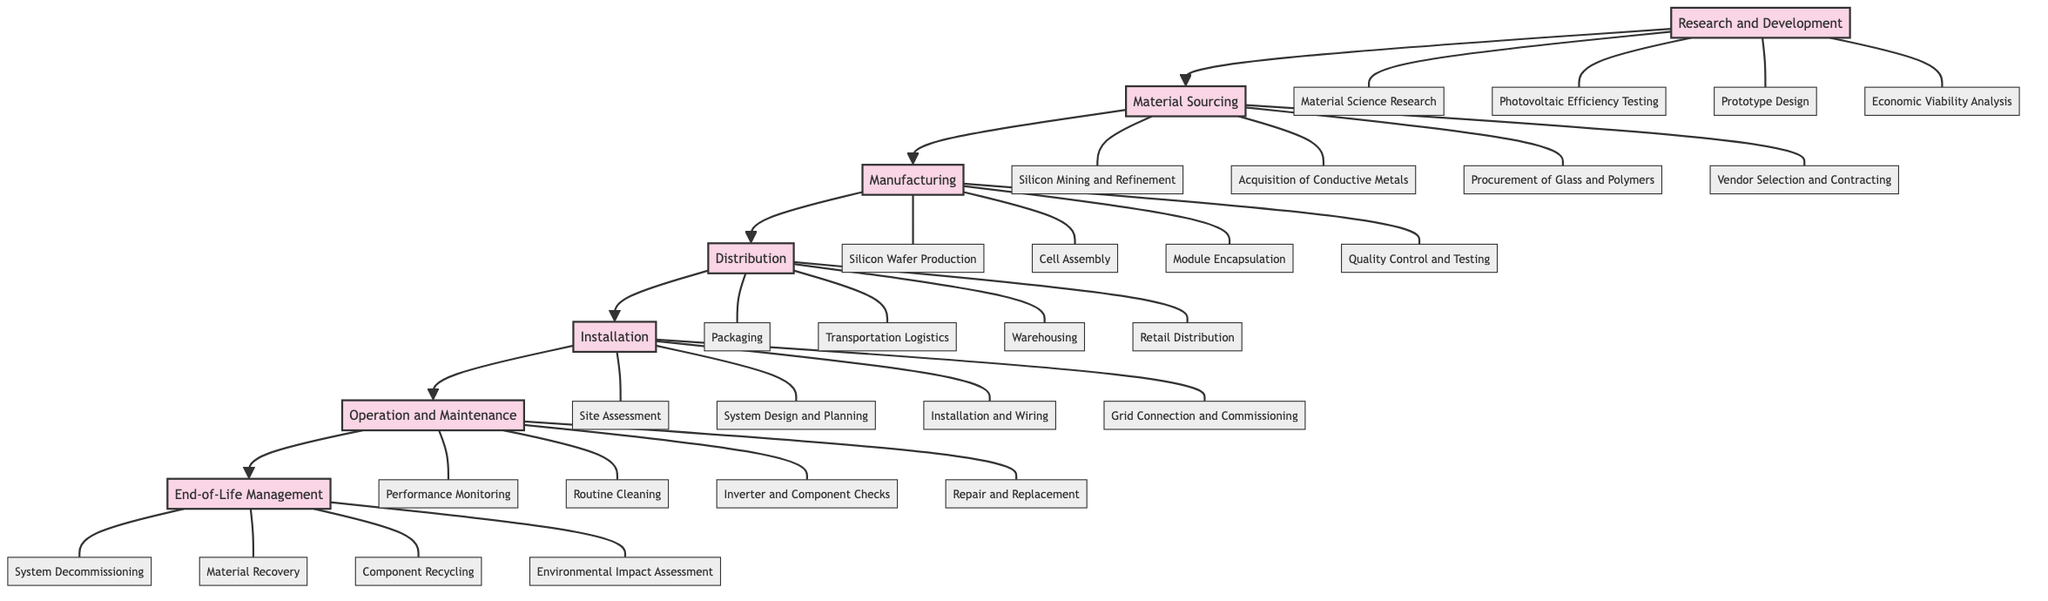What is the first phase in the lifecycle of a solar panel? The diagram indicates that the lifecycle begins with the phase "Research and Development," which is the first node in the sequence.
Answer: Research and Development How many activities are listed under the "Manufacturing" phase? The "Manufacturing" phase contains four activities: "Silicon Wafer Production," "Cell Assembly," "Module Encapsulation," and "Quality Control and Testing." Counting these gives a total of four activities.
Answer: 4 What is the last phase before "End-of-Life Management"? The diagram shows that "Operation and Maintenance" comes directly before "End-of-Life Management" in the flow, which indicates that it is the preceding phase.
Answer: Operation and Maintenance Which activity is the second in the "Distribution" phase? The activities under the "Distribution" phase are listed in order. The second activity listed is "Transportation Logistics."
Answer: Transportation Logistics What are the two main activities in the "Installation" phase? The diagram provides four activities under the "Installation" phase, but the two main activities would refer to the first two listed: "Site Assessment" and "System Design and Planning."
Answer: Site Assessment, System Design and Planning If a solar panel is decommissioned, which phase does it enter next? According to the flow in the diagram, once a solar panel is decommissioned in the "End-of-Life Management" phase, there are no subsequent phases, indicating it is the final step in the lifecycle.
Answer: None How many phases are involved in the lifecycle of a solar panel? The diagram lists a total of seven distinct phases from "Research and Development" to "End-of-Life Management," indicating that the lifecycle consists of seven phases.
Answer: 7 What activity follows "Component Recycling" in the diagram? The diagram indicates that "Environmental Impact Assessment" is the activity that follows "Component Recycling" in the "End-of-Life Management" phase.
Answer: Environmental Impact Assessment Which phase includes "Quality Control and Testing"? The activity "Quality Control and Testing" is specifically listed under the "Manufacturing" phase of the lifecycle in the diagram.
Answer: Manufacturing 